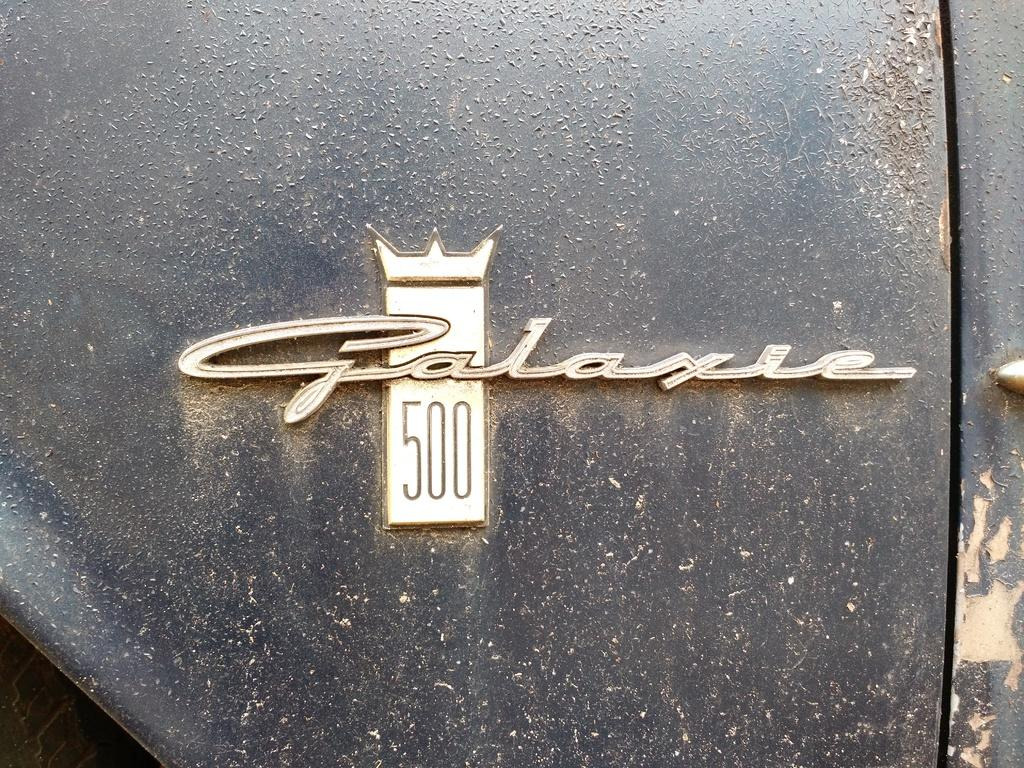What is the main feature of the image? The main feature of the image is a logo. What is the color of the surface on which the logo is placed? The logo is on a black color surface. Is there a receipt attached to the logo in the image? There is no mention of a receipt in the image, so it cannot be determined if one is present. 